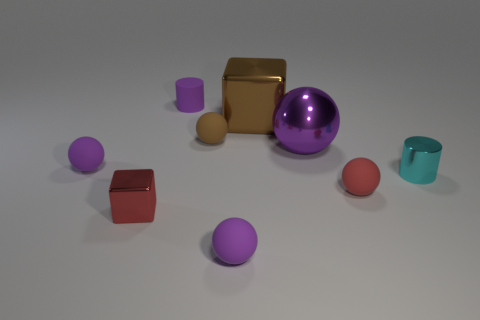Do the small metallic thing that is right of the metallic sphere and the metal object that is behind the tiny brown rubber ball have the same color?
Offer a terse response. No. How many other things are made of the same material as the cyan object?
Your answer should be very brief. 3. Are there any cyan rubber blocks?
Your answer should be very brief. No. Is the material of the ball that is to the left of the tiny purple cylinder the same as the small brown ball?
Keep it short and to the point. Yes. There is a purple object that is the same shape as the tiny cyan metal object; what is its material?
Keep it short and to the point. Rubber. There is a big thing that is the same color as the small rubber cylinder; what is its material?
Provide a succinct answer. Metal. Are there fewer large brown things than tiny green metal cylinders?
Provide a short and direct response. No. Is the color of the cylinder that is in front of the brown cube the same as the rubber cylinder?
Ensure brevity in your answer.  No. There is a big ball that is made of the same material as the cyan thing; what color is it?
Offer a terse response. Purple. Is the red shiny cube the same size as the brown sphere?
Offer a terse response. Yes. 